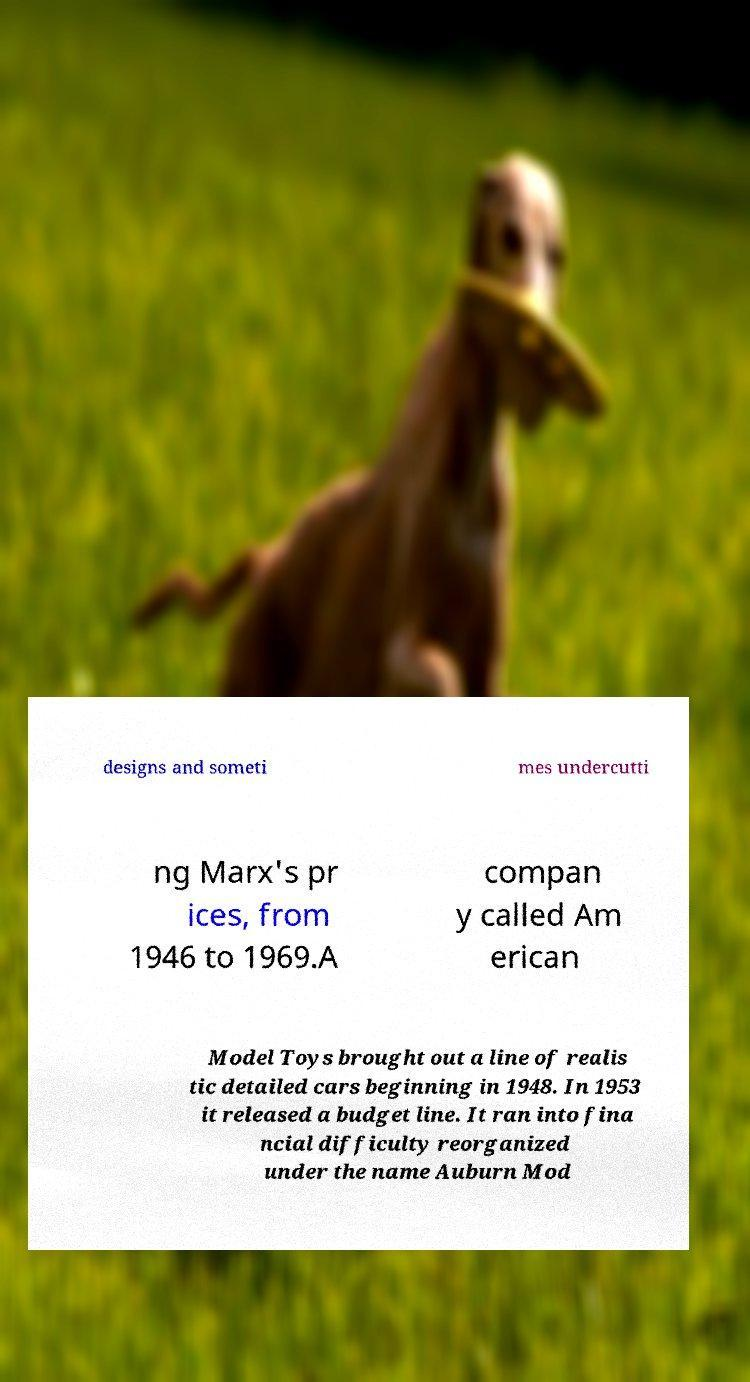Please read and relay the text visible in this image. What does it say? designs and someti mes undercutti ng Marx's pr ices, from 1946 to 1969.A compan y called Am erican Model Toys brought out a line of realis tic detailed cars beginning in 1948. In 1953 it released a budget line. It ran into fina ncial difficulty reorganized under the name Auburn Mod 